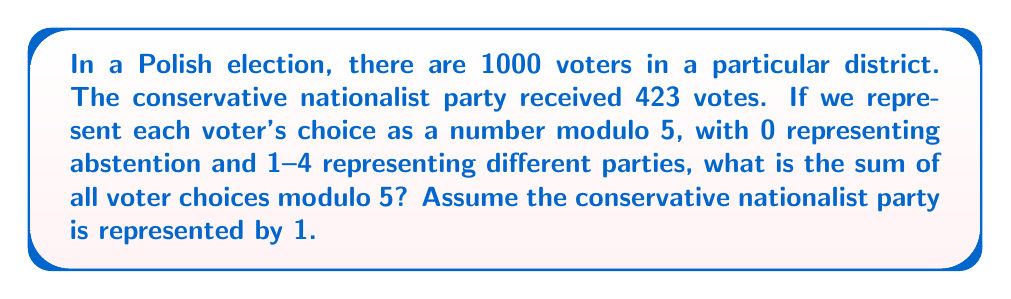What is the answer to this math problem? Let's approach this step-by-step:

1) We know that 423 voters chose the conservative nationalist party, represented by 1 mod 5.

2) The remaining 577 voters (1000 - 423) are distributed among abstentions (0 mod 5) and other parties (2, 3, 4 mod 5).

3) The sum of all voter choices modulo 5 can be represented as:

   $$(423 \cdot 1 + x_0 \cdot 0 + x_2 \cdot 2 + x_3 \cdot 3 + x_4 \cdot 4) \pmod{5}$$

   where $x_0$, $x_2$, $x_3$, and $x_4$ are the number of voters who abstained or voted for other parties.

4) We don't need to know the exact values of $x_0$, $x_2$, $x_3$, and $x_4$. We only need their sum to be 577.

5) Using the properties of modular arithmetic:

   $$(423 \cdot 1 + x_0 \cdot 0 + x_2 \cdot 2 + x_3 \cdot 3 + x_4 \cdot 4) \pmod{5}$$
   $$\equiv (423 + 2x_2 + 3x_3 + 4x_4) \pmod{5}$$
   $$\equiv (423 + 2x_2 + 3x_3 - x_4) \pmod{5}$$ (since $4 \equiv -1 \pmod{5}$)

6) Now, $423 \equiv 3 \pmod{5}$, so we have:

   $$(3 + 2x_2 + 3x_3 - x_4) \pmod{5}$$

7) The sum $x_2 + x_3 + x_4 = 577 - x_0$, but this doesn't affect our calculation modulo 5.

8) Therefore, regardless of how the remaining votes are distributed, the sum will always be congruent to 3 modulo 5.
Answer: The sum of all voter choices is congruent to 3 modulo 5. 